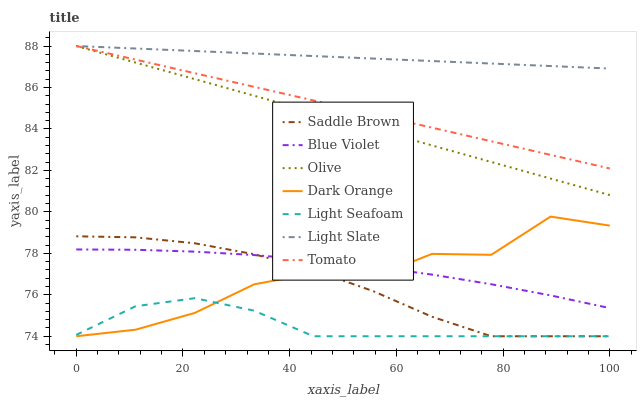Does Light Seafoam have the minimum area under the curve?
Answer yes or no. Yes. Does Light Slate have the maximum area under the curve?
Answer yes or no. Yes. Does Dark Orange have the minimum area under the curve?
Answer yes or no. No. Does Dark Orange have the maximum area under the curve?
Answer yes or no. No. Is Light Slate the smoothest?
Answer yes or no. Yes. Is Dark Orange the roughest?
Answer yes or no. Yes. Is Dark Orange the smoothest?
Answer yes or no. No. Is Light Slate the roughest?
Answer yes or no. No. Does Dark Orange have the lowest value?
Answer yes or no. Yes. Does Light Slate have the lowest value?
Answer yes or no. No. Does Olive have the highest value?
Answer yes or no. Yes. Does Dark Orange have the highest value?
Answer yes or no. No. Is Dark Orange less than Tomato?
Answer yes or no. Yes. Is Olive greater than Blue Violet?
Answer yes or no. Yes. Does Dark Orange intersect Blue Violet?
Answer yes or no. Yes. Is Dark Orange less than Blue Violet?
Answer yes or no. No. Is Dark Orange greater than Blue Violet?
Answer yes or no. No. Does Dark Orange intersect Tomato?
Answer yes or no. No. 